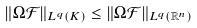Convert formula to latex. <formula><loc_0><loc_0><loc_500><loc_500>\| \Omega { \mathcal { F } } \| _ { L ^ { q } ( K ) } \leq \| \Omega { \mathcal { F } } \| _ { L ^ { q } ( { \mathbb { R } } ^ { n } ) }</formula> 